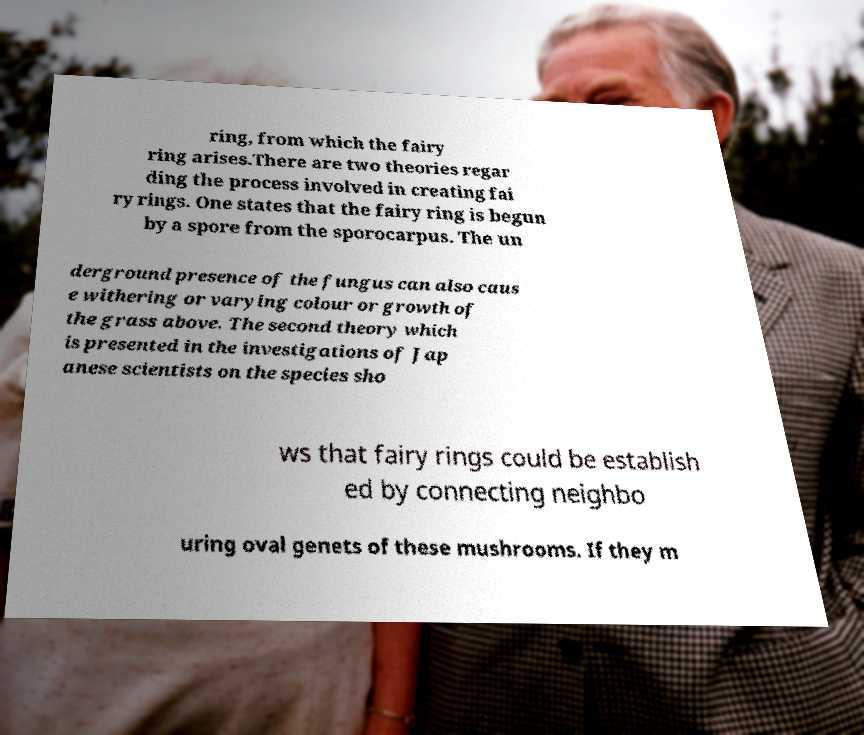Please identify and transcribe the text found in this image. ring, from which the fairy ring arises.There are two theories regar ding the process involved in creating fai ry rings. One states that the fairy ring is begun by a spore from the sporocarpus. The un derground presence of the fungus can also caus e withering or varying colour or growth of the grass above. The second theory which is presented in the investigations of Jap anese scientists on the species sho ws that fairy rings could be establish ed by connecting neighbo uring oval genets of these mushrooms. If they m 